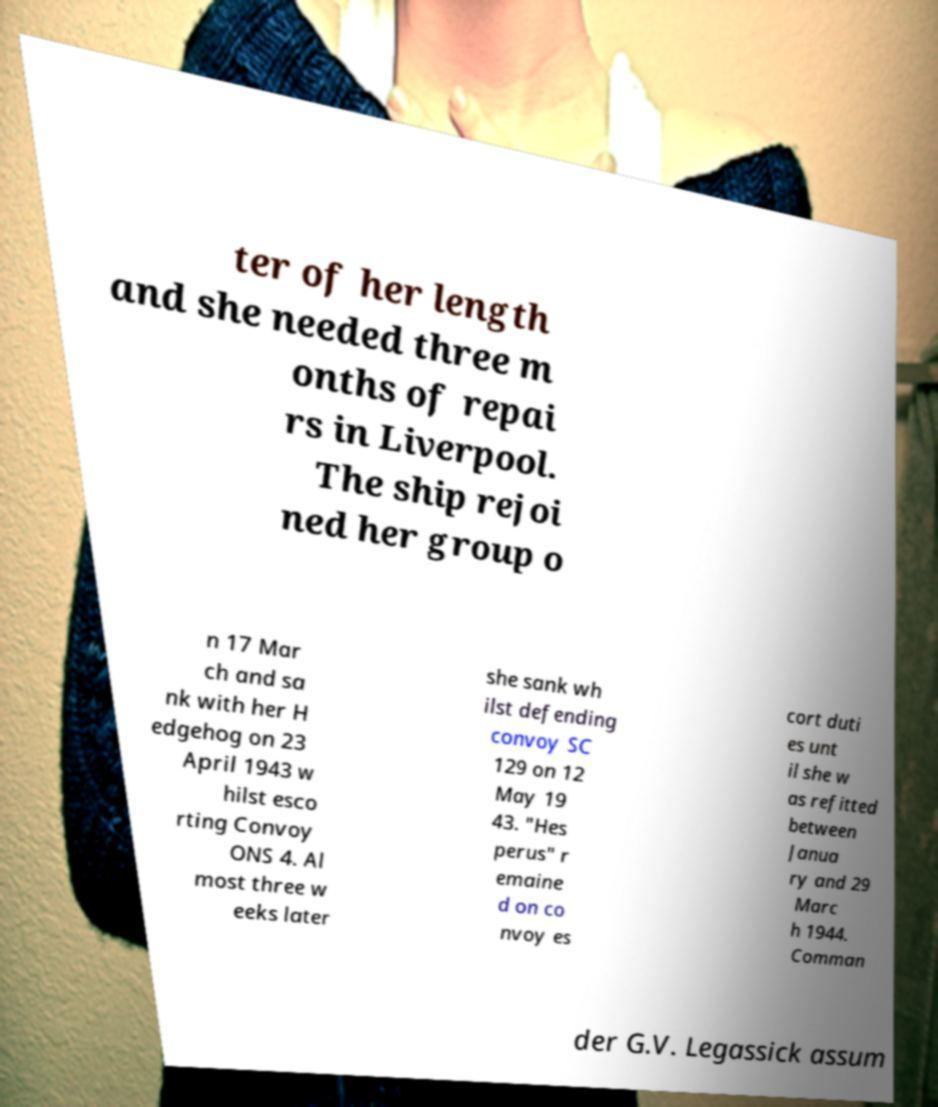Can you accurately transcribe the text from the provided image for me? ter of her length and she needed three m onths of repai rs in Liverpool. The ship rejoi ned her group o n 17 Mar ch and sa nk with her H edgehog on 23 April 1943 w hilst esco rting Convoy ONS 4. Al most three w eeks later she sank wh ilst defending convoy SC 129 on 12 May 19 43. "Hes perus" r emaine d on co nvoy es cort duti es unt il she w as refitted between Janua ry and 29 Marc h 1944. Comman der G.V. Legassick assum 